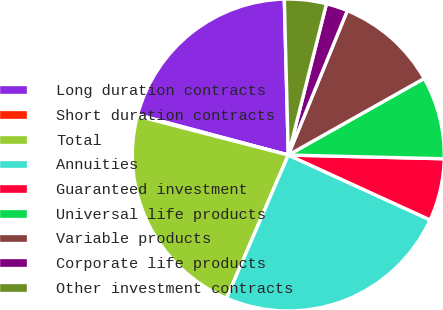<chart> <loc_0><loc_0><loc_500><loc_500><pie_chart><fcel>Long duration contracts<fcel>Short duration contracts<fcel>Total<fcel>Annuities<fcel>Guaranteed investment<fcel>Universal life products<fcel>Variable products<fcel>Corporate life products<fcel>Other investment contracts<nl><fcel>20.44%<fcel>0.13%<fcel>22.55%<fcel>24.65%<fcel>6.45%<fcel>8.55%<fcel>10.66%<fcel>2.24%<fcel>4.34%<nl></chart> 